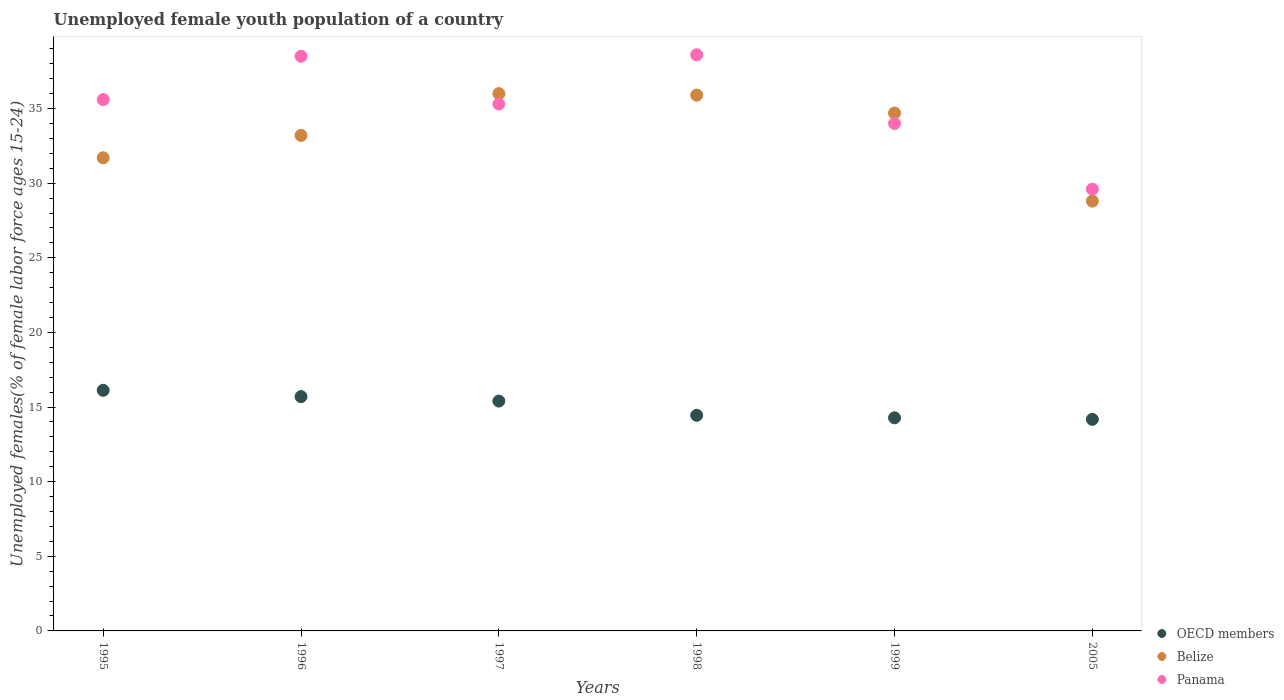What is the percentage of unemployed female youth population in Panama in 1999?
Your response must be concise. 34. Across all years, what is the minimum percentage of unemployed female youth population in OECD members?
Ensure brevity in your answer.  14.18. What is the total percentage of unemployed female youth population in Belize in the graph?
Provide a succinct answer. 200.3. What is the difference between the percentage of unemployed female youth population in Belize in 1997 and that in 1999?
Ensure brevity in your answer.  1.3. What is the difference between the percentage of unemployed female youth population in Belize in 1995 and the percentage of unemployed female youth population in OECD members in 1996?
Provide a short and direct response. 16. What is the average percentage of unemployed female youth population in OECD members per year?
Keep it short and to the point. 15.02. In the year 1995, what is the difference between the percentage of unemployed female youth population in Belize and percentage of unemployed female youth population in OECD members?
Make the answer very short. 15.58. In how many years, is the percentage of unemployed female youth population in Belize greater than 20 %?
Offer a very short reply. 6. What is the ratio of the percentage of unemployed female youth population in Panama in 1997 to that in 1998?
Your answer should be compact. 0.91. Is the difference between the percentage of unemployed female youth population in Belize in 1996 and 1998 greater than the difference between the percentage of unemployed female youth population in OECD members in 1996 and 1998?
Offer a very short reply. No. What is the difference between the highest and the second highest percentage of unemployed female youth population in OECD members?
Keep it short and to the point. 0.42. What is the difference between the highest and the lowest percentage of unemployed female youth population in OECD members?
Make the answer very short. 1.94. In how many years, is the percentage of unemployed female youth population in Belize greater than the average percentage of unemployed female youth population in Belize taken over all years?
Your answer should be compact. 3. Is the sum of the percentage of unemployed female youth population in Panama in 1996 and 1999 greater than the maximum percentage of unemployed female youth population in Belize across all years?
Your answer should be very brief. Yes. Does the percentage of unemployed female youth population in Belize monotonically increase over the years?
Ensure brevity in your answer.  No. Is the percentage of unemployed female youth population in OECD members strictly less than the percentage of unemployed female youth population in Panama over the years?
Offer a very short reply. Yes. How many dotlines are there?
Offer a terse response. 3. How many years are there in the graph?
Keep it short and to the point. 6. What is the difference between two consecutive major ticks on the Y-axis?
Provide a succinct answer. 5. Does the graph contain grids?
Offer a terse response. No. How are the legend labels stacked?
Offer a very short reply. Vertical. What is the title of the graph?
Ensure brevity in your answer.  Unemployed female youth population of a country. What is the label or title of the Y-axis?
Provide a short and direct response. Unemployed females(% of female labor force ages 15-24). What is the Unemployed females(% of female labor force ages 15-24) of OECD members in 1995?
Provide a succinct answer. 16.12. What is the Unemployed females(% of female labor force ages 15-24) in Belize in 1995?
Offer a very short reply. 31.7. What is the Unemployed females(% of female labor force ages 15-24) in Panama in 1995?
Offer a terse response. 35.6. What is the Unemployed females(% of female labor force ages 15-24) in OECD members in 1996?
Your response must be concise. 15.7. What is the Unemployed females(% of female labor force ages 15-24) in Belize in 1996?
Provide a succinct answer. 33.2. What is the Unemployed females(% of female labor force ages 15-24) in Panama in 1996?
Give a very brief answer. 38.5. What is the Unemployed females(% of female labor force ages 15-24) of OECD members in 1997?
Keep it short and to the point. 15.4. What is the Unemployed females(% of female labor force ages 15-24) of Panama in 1997?
Keep it short and to the point. 35.3. What is the Unemployed females(% of female labor force ages 15-24) of OECD members in 1998?
Offer a very short reply. 14.45. What is the Unemployed females(% of female labor force ages 15-24) in Belize in 1998?
Ensure brevity in your answer.  35.9. What is the Unemployed females(% of female labor force ages 15-24) of Panama in 1998?
Give a very brief answer. 38.6. What is the Unemployed females(% of female labor force ages 15-24) of OECD members in 1999?
Provide a short and direct response. 14.28. What is the Unemployed females(% of female labor force ages 15-24) of Belize in 1999?
Offer a terse response. 34.7. What is the Unemployed females(% of female labor force ages 15-24) in Panama in 1999?
Ensure brevity in your answer.  34. What is the Unemployed females(% of female labor force ages 15-24) of OECD members in 2005?
Provide a short and direct response. 14.18. What is the Unemployed females(% of female labor force ages 15-24) of Belize in 2005?
Make the answer very short. 28.8. What is the Unemployed females(% of female labor force ages 15-24) of Panama in 2005?
Your answer should be compact. 29.6. Across all years, what is the maximum Unemployed females(% of female labor force ages 15-24) of OECD members?
Provide a succinct answer. 16.12. Across all years, what is the maximum Unemployed females(% of female labor force ages 15-24) of Panama?
Your answer should be very brief. 38.6. Across all years, what is the minimum Unemployed females(% of female labor force ages 15-24) of OECD members?
Keep it short and to the point. 14.18. Across all years, what is the minimum Unemployed females(% of female labor force ages 15-24) of Belize?
Provide a short and direct response. 28.8. Across all years, what is the minimum Unemployed females(% of female labor force ages 15-24) in Panama?
Offer a terse response. 29.6. What is the total Unemployed females(% of female labor force ages 15-24) in OECD members in the graph?
Give a very brief answer. 90.12. What is the total Unemployed females(% of female labor force ages 15-24) in Belize in the graph?
Your answer should be compact. 200.3. What is the total Unemployed females(% of female labor force ages 15-24) in Panama in the graph?
Offer a terse response. 211.6. What is the difference between the Unemployed females(% of female labor force ages 15-24) of OECD members in 1995 and that in 1996?
Ensure brevity in your answer.  0.42. What is the difference between the Unemployed females(% of female labor force ages 15-24) of Belize in 1995 and that in 1996?
Your answer should be compact. -1.5. What is the difference between the Unemployed females(% of female labor force ages 15-24) of Panama in 1995 and that in 1996?
Your response must be concise. -2.9. What is the difference between the Unemployed females(% of female labor force ages 15-24) of OECD members in 1995 and that in 1997?
Give a very brief answer. 0.72. What is the difference between the Unemployed females(% of female labor force ages 15-24) of OECD members in 1995 and that in 1998?
Offer a terse response. 1.67. What is the difference between the Unemployed females(% of female labor force ages 15-24) of Belize in 1995 and that in 1998?
Give a very brief answer. -4.2. What is the difference between the Unemployed females(% of female labor force ages 15-24) in OECD members in 1995 and that in 1999?
Offer a very short reply. 1.84. What is the difference between the Unemployed females(% of female labor force ages 15-24) of Panama in 1995 and that in 1999?
Your response must be concise. 1.6. What is the difference between the Unemployed females(% of female labor force ages 15-24) of OECD members in 1995 and that in 2005?
Your response must be concise. 1.94. What is the difference between the Unemployed females(% of female labor force ages 15-24) of Belize in 1995 and that in 2005?
Give a very brief answer. 2.9. What is the difference between the Unemployed females(% of female labor force ages 15-24) of OECD members in 1996 and that in 1997?
Provide a short and direct response. 0.3. What is the difference between the Unemployed females(% of female labor force ages 15-24) in Panama in 1996 and that in 1997?
Offer a very short reply. 3.2. What is the difference between the Unemployed females(% of female labor force ages 15-24) in OECD members in 1996 and that in 1998?
Your answer should be compact. 1.25. What is the difference between the Unemployed females(% of female labor force ages 15-24) of Belize in 1996 and that in 1998?
Ensure brevity in your answer.  -2.7. What is the difference between the Unemployed females(% of female labor force ages 15-24) in Panama in 1996 and that in 1998?
Give a very brief answer. -0.1. What is the difference between the Unemployed females(% of female labor force ages 15-24) in OECD members in 1996 and that in 1999?
Your answer should be compact. 1.42. What is the difference between the Unemployed females(% of female labor force ages 15-24) in Panama in 1996 and that in 1999?
Give a very brief answer. 4.5. What is the difference between the Unemployed females(% of female labor force ages 15-24) of OECD members in 1996 and that in 2005?
Your answer should be very brief. 1.52. What is the difference between the Unemployed females(% of female labor force ages 15-24) in Belize in 1996 and that in 2005?
Give a very brief answer. 4.4. What is the difference between the Unemployed females(% of female labor force ages 15-24) of OECD members in 1997 and that in 1998?
Provide a short and direct response. 0.95. What is the difference between the Unemployed females(% of female labor force ages 15-24) in Panama in 1997 and that in 1998?
Give a very brief answer. -3.3. What is the difference between the Unemployed females(% of female labor force ages 15-24) in OECD members in 1997 and that in 1999?
Your response must be concise. 1.12. What is the difference between the Unemployed females(% of female labor force ages 15-24) in Panama in 1997 and that in 1999?
Ensure brevity in your answer.  1.3. What is the difference between the Unemployed females(% of female labor force ages 15-24) in OECD members in 1997 and that in 2005?
Ensure brevity in your answer.  1.22. What is the difference between the Unemployed females(% of female labor force ages 15-24) of OECD members in 1998 and that in 1999?
Your response must be concise. 0.17. What is the difference between the Unemployed females(% of female labor force ages 15-24) of Panama in 1998 and that in 1999?
Make the answer very short. 4.6. What is the difference between the Unemployed females(% of female labor force ages 15-24) of OECD members in 1998 and that in 2005?
Keep it short and to the point. 0.27. What is the difference between the Unemployed females(% of female labor force ages 15-24) of Belize in 1998 and that in 2005?
Provide a succinct answer. 7.1. What is the difference between the Unemployed females(% of female labor force ages 15-24) of OECD members in 1999 and that in 2005?
Ensure brevity in your answer.  0.1. What is the difference between the Unemployed females(% of female labor force ages 15-24) in Panama in 1999 and that in 2005?
Offer a terse response. 4.4. What is the difference between the Unemployed females(% of female labor force ages 15-24) in OECD members in 1995 and the Unemployed females(% of female labor force ages 15-24) in Belize in 1996?
Offer a terse response. -17.08. What is the difference between the Unemployed females(% of female labor force ages 15-24) in OECD members in 1995 and the Unemployed females(% of female labor force ages 15-24) in Panama in 1996?
Keep it short and to the point. -22.38. What is the difference between the Unemployed females(% of female labor force ages 15-24) in Belize in 1995 and the Unemployed females(% of female labor force ages 15-24) in Panama in 1996?
Your answer should be very brief. -6.8. What is the difference between the Unemployed females(% of female labor force ages 15-24) in OECD members in 1995 and the Unemployed females(% of female labor force ages 15-24) in Belize in 1997?
Your answer should be very brief. -19.88. What is the difference between the Unemployed females(% of female labor force ages 15-24) in OECD members in 1995 and the Unemployed females(% of female labor force ages 15-24) in Panama in 1997?
Offer a terse response. -19.18. What is the difference between the Unemployed females(% of female labor force ages 15-24) in OECD members in 1995 and the Unemployed females(% of female labor force ages 15-24) in Belize in 1998?
Your answer should be very brief. -19.78. What is the difference between the Unemployed females(% of female labor force ages 15-24) in OECD members in 1995 and the Unemployed females(% of female labor force ages 15-24) in Panama in 1998?
Make the answer very short. -22.48. What is the difference between the Unemployed females(% of female labor force ages 15-24) in Belize in 1995 and the Unemployed females(% of female labor force ages 15-24) in Panama in 1998?
Offer a very short reply. -6.9. What is the difference between the Unemployed females(% of female labor force ages 15-24) of OECD members in 1995 and the Unemployed females(% of female labor force ages 15-24) of Belize in 1999?
Your answer should be very brief. -18.58. What is the difference between the Unemployed females(% of female labor force ages 15-24) of OECD members in 1995 and the Unemployed females(% of female labor force ages 15-24) of Panama in 1999?
Give a very brief answer. -17.88. What is the difference between the Unemployed females(% of female labor force ages 15-24) of OECD members in 1995 and the Unemployed females(% of female labor force ages 15-24) of Belize in 2005?
Your answer should be compact. -12.68. What is the difference between the Unemployed females(% of female labor force ages 15-24) of OECD members in 1995 and the Unemployed females(% of female labor force ages 15-24) of Panama in 2005?
Your answer should be very brief. -13.48. What is the difference between the Unemployed females(% of female labor force ages 15-24) of Belize in 1995 and the Unemployed females(% of female labor force ages 15-24) of Panama in 2005?
Keep it short and to the point. 2.1. What is the difference between the Unemployed females(% of female labor force ages 15-24) in OECD members in 1996 and the Unemployed females(% of female labor force ages 15-24) in Belize in 1997?
Make the answer very short. -20.3. What is the difference between the Unemployed females(% of female labor force ages 15-24) in OECD members in 1996 and the Unemployed females(% of female labor force ages 15-24) in Panama in 1997?
Offer a very short reply. -19.6. What is the difference between the Unemployed females(% of female labor force ages 15-24) in OECD members in 1996 and the Unemployed females(% of female labor force ages 15-24) in Belize in 1998?
Provide a succinct answer. -20.2. What is the difference between the Unemployed females(% of female labor force ages 15-24) in OECD members in 1996 and the Unemployed females(% of female labor force ages 15-24) in Panama in 1998?
Ensure brevity in your answer.  -22.9. What is the difference between the Unemployed females(% of female labor force ages 15-24) in OECD members in 1996 and the Unemployed females(% of female labor force ages 15-24) in Belize in 1999?
Your answer should be compact. -19. What is the difference between the Unemployed females(% of female labor force ages 15-24) of OECD members in 1996 and the Unemployed females(% of female labor force ages 15-24) of Panama in 1999?
Make the answer very short. -18.3. What is the difference between the Unemployed females(% of female labor force ages 15-24) of OECD members in 1996 and the Unemployed females(% of female labor force ages 15-24) of Belize in 2005?
Make the answer very short. -13.1. What is the difference between the Unemployed females(% of female labor force ages 15-24) of OECD members in 1996 and the Unemployed females(% of female labor force ages 15-24) of Panama in 2005?
Provide a succinct answer. -13.9. What is the difference between the Unemployed females(% of female labor force ages 15-24) of Belize in 1996 and the Unemployed females(% of female labor force ages 15-24) of Panama in 2005?
Provide a short and direct response. 3.6. What is the difference between the Unemployed females(% of female labor force ages 15-24) in OECD members in 1997 and the Unemployed females(% of female labor force ages 15-24) in Belize in 1998?
Offer a terse response. -20.5. What is the difference between the Unemployed females(% of female labor force ages 15-24) of OECD members in 1997 and the Unemployed females(% of female labor force ages 15-24) of Panama in 1998?
Make the answer very short. -23.2. What is the difference between the Unemployed females(% of female labor force ages 15-24) in OECD members in 1997 and the Unemployed females(% of female labor force ages 15-24) in Belize in 1999?
Make the answer very short. -19.3. What is the difference between the Unemployed females(% of female labor force ages 15-24) of OECD members in 1997 and the Unemployed females(% of female labor force ages 15-24) of Panama in 1999?
Keep it short and to the point. -18.6. What is the difference between the Unemployed females(% of female labor force ages 15-24) of OECD members in 1997 and the Unemployed females(% of female labor force ages 15-24) of Belize in 2005?
Provide a short and direct response. -13.4. What is the difference between the Unemployed females(% of female labor force ages 15-24) in OECD members in 1997 and the Unemployed females(% of female labor force ages 15-24) in Panama in 2005?
Your answer should be very brief. -14.2. What is the difference between the Unemployed females(% of female labor force ages 15-24) in OECD members in 1998 and the Unemployed females(% of female labor force ages 15-24) in Belize in 1999?
Your answer should be very brief. -20.25. What is the difference between the Unemployed females(% of female labor force ages 15-24) of OECD members in 1998 and the Unemployed females(% of female labor force ages 15-24) of Panama in 1999?
Provide a succinct answer. -19.55. What is the difference between the Unemployed females(% of female labor force ages 15-24) in Belize in 1998 and the Unemployed females(% of female labor force ages 15-24) in Panama in 1999?
Ensure brevity in your answer.  1.9. What is the difference between the Unemployed females(% of female labor force ages 15-24) of OECD members in 1998 and the Unemployed females(% of female labor force ages 15-24) of Belize in 2005?
Offer a very short reply. -14.35. What is the difference between the Unemployed females(% of female labor force ages 15-24) of OECD members in 1998 and the Unemployed females(% of female labor force ages 15-24) of Panama in 2005?
Offer a terse response. -15.15. What is the difference between the Unemployed females(% of female labor force ages 15-24) in OECD members in 1999 and the Unemployed females(% of female labor force ages 15-24) in Belize in 2005?
Ensure brevity in your answer.  -14.52. What is the difference between the Unemployed females(% of female labor force ages 15-24) of OECD members in 1999 and the Unemployed females(% of female labor force ages 15-24) of Panama in 2005?
Your answer should be compact. -15.32. What is the difference between the Unemployed females(% of female labor force ages 15-24) of Belize in 1999 and the Unemployed females(% of female labor force ages 15-24) of Panama in 2005?
Keep it short and to the point. 5.1. What is the average Unemployed females(% of female labor force ages 15-24) in OECD members per year?
Offer a very short reply. 15.02. What is the average Unemployed females(% of female labor force ages 15-24) of Belize per year?
Your response must be concise. 33.38. What is the average Unemployed females(% of female labor force ages 15-24) in Panama per year?
Make the answer very short. 35.27. In the year 1995, what is the difference between the Unemployed females(% of female labor force ages 15-24) of OECD members and Unemployed females(% of female labor force ages 15-24) of Belize?
Offer a very short reply. -15.58. In the year 1995, what is the difference between the Unemployed females(% of female labor force ages 15-24) of OECD members and Unemployed females(% of female labor force ages 15-24) of Panama?
Your answer should be very brief. -19.48. In the year 1995, what is the difference between the Unemployed females(% of female labor force ages 15-24) of Belize and Unemployed females(% of female labor force ages 15-24) of Panama?
Your answer should be compact. -3.9. In the year 1996, what is the difference between the Unemployed females(% of female labor force ages 15-24) in OECD members and Unemployed females(% of female labor force ages 15-24) in Belize?
Offer a very short reply. -17.5. In the year 1996, what is the difference between the Unemployed females(% of female labor force ages 15-24) of OECD members and Unemployed females(% of female labor force ages 15-24) of Panama?
Your response must be concise. -22.8. In the year 1997, what is the difference between the Unemployed females(% of female labor force ages 15-24) in OECD members and Unemployed females(% of female labor force ages 15-24) in Belize?
Give a very brief answer. -20.6. In the year 1997, what is the difference between the Unemployed females(% of female labor force ages 15-24) of OECD members and Unemployed females(% of female labor force ages 15-24) of Panama?
Offer a very short reply. -19.9. In the year 1998, what is the difference between the Unemployed females(% of female labor force ages 15-24) of OECD members and Unemployed females(% of female labor force ages 15-24) of Belize?
Offer a terse response. -21.45. In the year 1998, what is the difference between the Unemployed females(% of female labor force ages 15-24) in OECD members and Unemployed females(% of female labor force ages 15-24) in Panama?
Your response must be concise. -24.15. In the year 1998, what is the difference between the Unemployed females(% of female labor force ages 15-24) of Belize and Unemployed females(% of female labor force ages 15-24) of Panama?
Give a very brief answer. -2.7. In the year 1999, what is the difference between the Unemployed females(% of female labor force ages 15-24) in OECD members and Unemployed females(% of female labor force ages 15-24) in Belize?
Offer a very short reply. -20.42. In the year 1999, what is the difference between the Unemployed females(% of female labor force ages 15-24) in OECD members and Unemployed females(% of female labor force ages 15-24) in Panama?
Offer a very short reply. -19.72. In the year 1999, what is the difference between the Unemployed females(% of female labor force ages 15-24) of Belize and Unemployed females(% of female labor force ages 15-24) of Panama?
Provide a short and direct response. 0.7. In the year 2005, what is the difference between the Unemployed females(% of female labor force ages 15-24) of OECD members and Unemployed females(% of female labor force ages 15-24) of Belize?
Offer a very short reply. -14.62. In the year 2005, what is the difference between the Unemployed females(% of female labor force ages 15-24) in OECD members and Unemployed females(% of female labor force ages 15-24) in Panama?
Your answer should be compact. -15.42. In the year 2005, what is the difference between the Unemployed females(% of female labor force ages 15-24) of Belize and Unemployed females(% of female labor force ages 15-24) of Panama?
Offer a very short reply. -0.8. What is the ratio of the Unemployed females(% of female labor force ages 15-24) of OECD members in 1995 to that in 1996?
Ensure brevity in your answer.  1.03. What is the ratio of the Unemployed females(% of female labor force ages 15-24) in Belize in 1995 to that in 1996?
Your answer should be compact. 0.95. What is the ratio of the Unemployed females(% of female labor force ages 15-24) of Panama in 1995 to that in 1996?
Your response must be concise. 0.92. What is the ratio of the Unemployed females(% of female labor force ages 15-24) of OECD members in 1995 to that in 1997?
Offer a terse response. 1.05. What is the ratio of the Unemployed females(% of female labor force ages 15-24) of Belize in 1995 to that in 1997?
Your response must be concise. 0.88. What is the ratio of the Unemployed females(% of female labor force ages 15-24) of Panama in 1995 to that in 1997?
Ensure brevity in your answer.  1.01. What is the ratio of the Unemployed females(% of female labor force ages 15-24) of OECD members in 1995 to that in 1998?
Keep it short and to the point. 1.12. What is the ratio of the Unemployed females(% of female labor force ages 15-24) of Belize in 1995 to that in 1998?
Offer a terse response. 0.88. What is the ratio of the Unemployed females(% of female labor force ages 15-24) in Panama in 1995 to that in 1998?
Provide a succinct answer. 0.92. What is the ratio of the Unemployed females(% of female labor force ages 15-24) of OECD members in 1995 to that in 1999?
Provide a succinct answer. 1.13. What is the ratio of the Unemployed females(% of female labor force ages 15-24) in Belize in 1995 to that in 1999?
Provide a succinct answer. 0.91. What is the ratio of the Unemployed females(% of female labor force ages 15-24) of Panama in 1995 to that in 1999?
Provide a succinct answer. 1.05. What is the ratio of the Unemployed females(% of female labor force ages 15-24) of OECD members in 1995 to that in 2005?
Provide a succinct answer. 1.14. What is the ratio of the Unemployed females(% of female labor force ages 15-24) of Belize in 1995 to that in 2005?
Your answer should be very brief. 1.1. What is the ratio of the Unemployed females(% of female labor force ages 15-24) of Panama in 1995 to that in 2005?
Your answer should be compact. 1.2. What is the ratio of the Unemployed females(% of female labor force ages 15-24) in OECD members in 1996 to that in 1997?
Offer a terse response. 1.02. What is the ratio of the Unemployed females(% of female labor force ages 15-24) of Belize in 1996 to that in 1997?
Make the answer very short. 0.92. What is the ratio of the Unemployed females(% of female labor force ages 15-24) of Panama in 1996 to that in 1997?
Ensure brevity in your answer.  1.09. What is the ratio of the Unemployed females(% of female labor force ages 15-24) in OECD members in 1996 to that in 1998?
Your response must be concise. 1.09. What is the ratio of the Unemployed females(% of female labor force ages 15-24) in Belize in 1996 to that in 1998?
Give a very brief answer. 0.92. What is the ratio of the Unemployed females(% of female labor force ages 15-24) of OECD members in 1996 to that in 1999?
Your answer should be compact. 1.1. What is the ratio of the Unemployed females(% of female labor force ages 15-24) of Belize in 1996 to that in 1999?
Provide a succinct answer. 0.96. What is the ratio of the Unemployed females(% of female labor force ages 15-24) of Panama in 1996 to that in 1999?
Offer a very short reply. 1.13. What is the ratio of the Unemployed females(% of female labor force ages 15-24) of OECD members in 1996 to that in 2005?
Provide a short and direct response. 1.11. What is the ratio of the Unemployed females(% of female labor force ages 15-24) in Belize in 1996 to that in 2005?
Make the answer very short. 1.15. What is the ratio of the Unemployed females(% of female labor force ages 15-24) in Panama in 1996 to that in 2005?
Your answer should be very brief. 1.3. What is the ratio of the Unemployed females(% of female labor force ages 15-24) in OECD members in 1997 to that in 1998?
Ensure brevity in your answer.  1.07. What is the ratio of the Unemployed females(% of female labor force ages 15-24) of Belize in 1997 to that in 1998?
Your answer should be compact. 1. What is the ratio of the Unemployed females(% of female labor force ages 15-24) of Panama in 1997 to that in 1998?
Your response must be concise. 0.91. What is the ratio of the Unemployed females(% of female labor force ages 15-24) in OECD members in 1997 to that in 1999?
Ensure brevity in your answer.  1.08. What is the ratio of the Unemployed females(% of female labor force ages 15-24) of Belize in 1997 to that in 1999?
Your answer should be compact. 1.04. What is the ratio of the Unemployed females(% of female labor force ages 15-24) in Panama in 1997 to that in 1999?
Your answer should be compact. 1.04. What is the ratio of the Unemployed females(% of female labor force ages 15-24) in OECD members in 1997 to that in 2005?
Offer a very short reply. 1.09. What is the ratio of the Unemployed females(% of female labor force ages 15-24) in Panama in 1997 to that in 2005?
Offer a terse response. 1.19. What is the ratio of the Unemployed females(% of female labor force ages 15-24) in OECD members in 1998 to that in 1999?
Provide a short and direct response. 1.01. What is the ratio of the Unemployed females(% of female labor force ages 15-24) of Belize in 1998 to that in 1999?
Offer a very short reply. 1.03. What is the ratio of the Unemployed females(% of female labor force ages 15-24) in Panama in 1998 to that in 1999?
Give a very brief answer. 1.14. What is the ratio of the Unemployed females(% of female labor force ages 15-24) of OECD members in 1998 to that in 2005?
Make the answer very short. 1.02. What is the ratio of the Unemployed females(% of female labor force ages 15-24) in Belize in 1998 to that in 2005?
Your answer should be very brief. 1.25. What is the ratio of the Unemployed females(% of female labor force ages 15-24) of Panama in 1998 to that in 2005?
Ensure brevity in your answer.  1.3. What is the ratio of the Unemployed females(% of female labor force ages 15-24) of OECD members in 1999 to that in 2005?
Your answer should be very brief. 1.01. What is the ratio of the Unemployed females(% of female labor force ages 15-24) of Belize in 1999 to that in 2005?
Your answer should be very brief. 1.2. What is the ratio of the Unemployed females(% of female labor force ages 15-24) of Panama in 1999 to that in 2005?
Your answer should be very brief. 1.15. What is the difference between the highest and the second highest Unemployed females(% of female labor force ages 15-24) of OECD members?
Your response must be concise. 0.42. What is the difference between the highest and the second highest Unemployed females(% of female labor force ages 15-24) in Panama?
Keep it short and to the point. 0.1. What is the difference between the highest and the lowest Unemployed females(% of female labor force ages 15-24) of OECD members?
Offer a terse response. 1.94. 